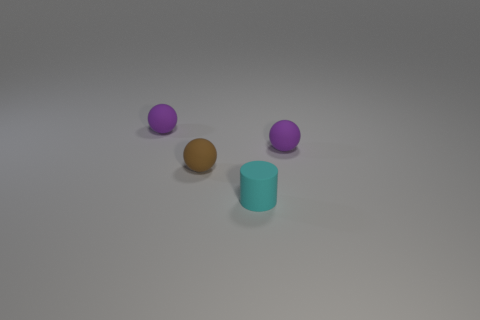Add 2 small spheres. How many objects exist? 6 Subtract all cylinders. How many objects are left? 3 Add 3 purple rubber spheres. How many purple rubber spheres are left? 5 Add 4 tiny matte spheres. How many tiny matte spheres exist? 7 Subtract 0 yellow cubes. How many objects are left? 4 Subtract all brown rubber objects. Subtract all rubber cylinders. How many objects are left? 2 